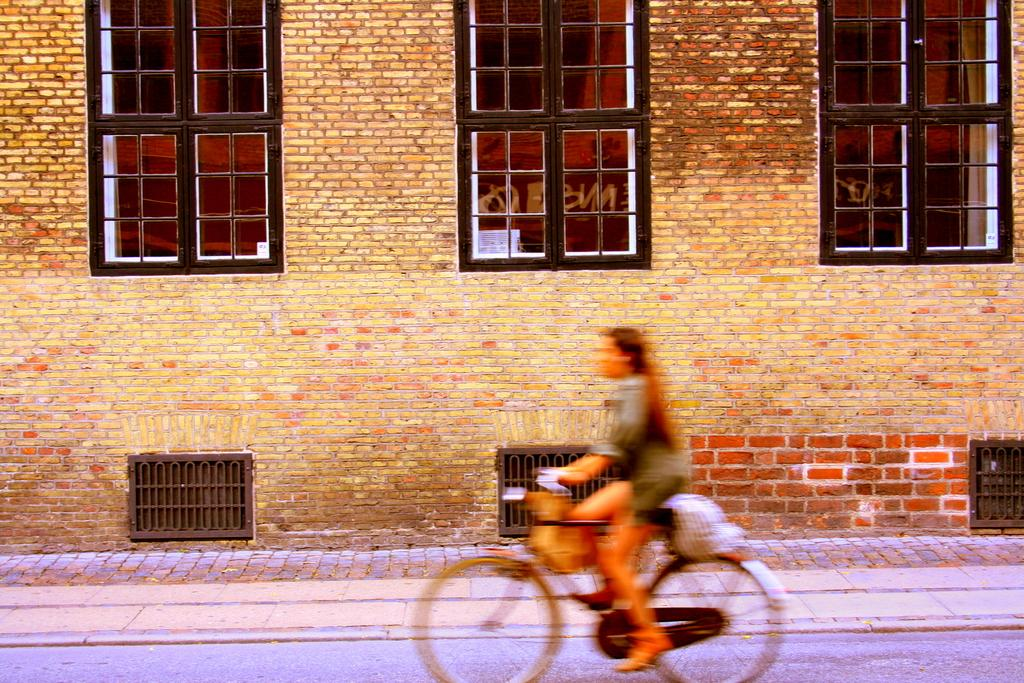What is the person in the image doing? The person is riding a bicycle in the image. Where is the person riding the bicycle? The person is on the road. What can be seen beside the road? There are windows, metal doors, and a wall beside the road. Can you describe the tiger swimming in the water beside the road? There is no tiger swimming in the water beside the road in the image. 